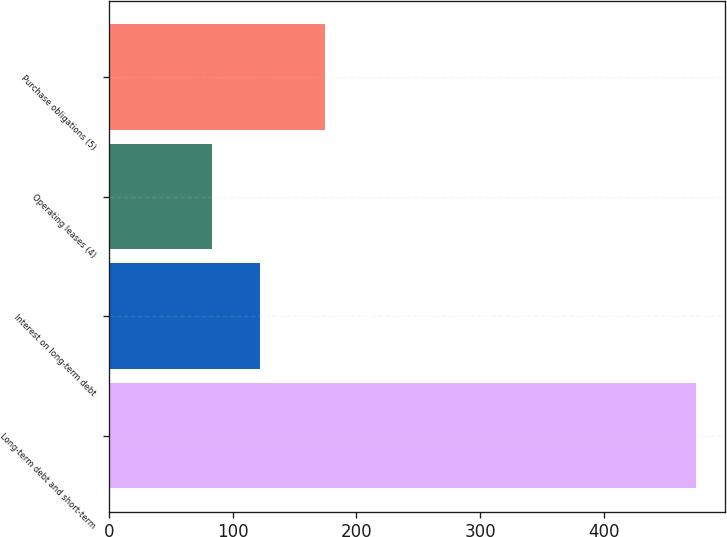<chart> <loc_0><loc_0><loc_500><loc_500><bar_chart><fcel>Long-term debt and short-term<fcel>Interest on long-term debt<fcel>Operating leases (4)<fcel>Purchase obligations (5)<nl><fcel>474<fcel>122.1<fcel>83<fcel>175<nl></chart> 